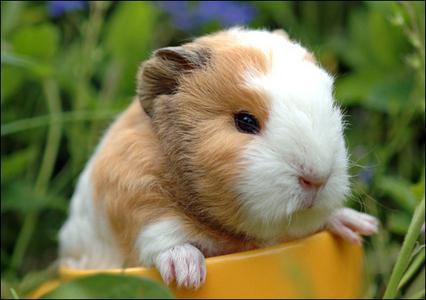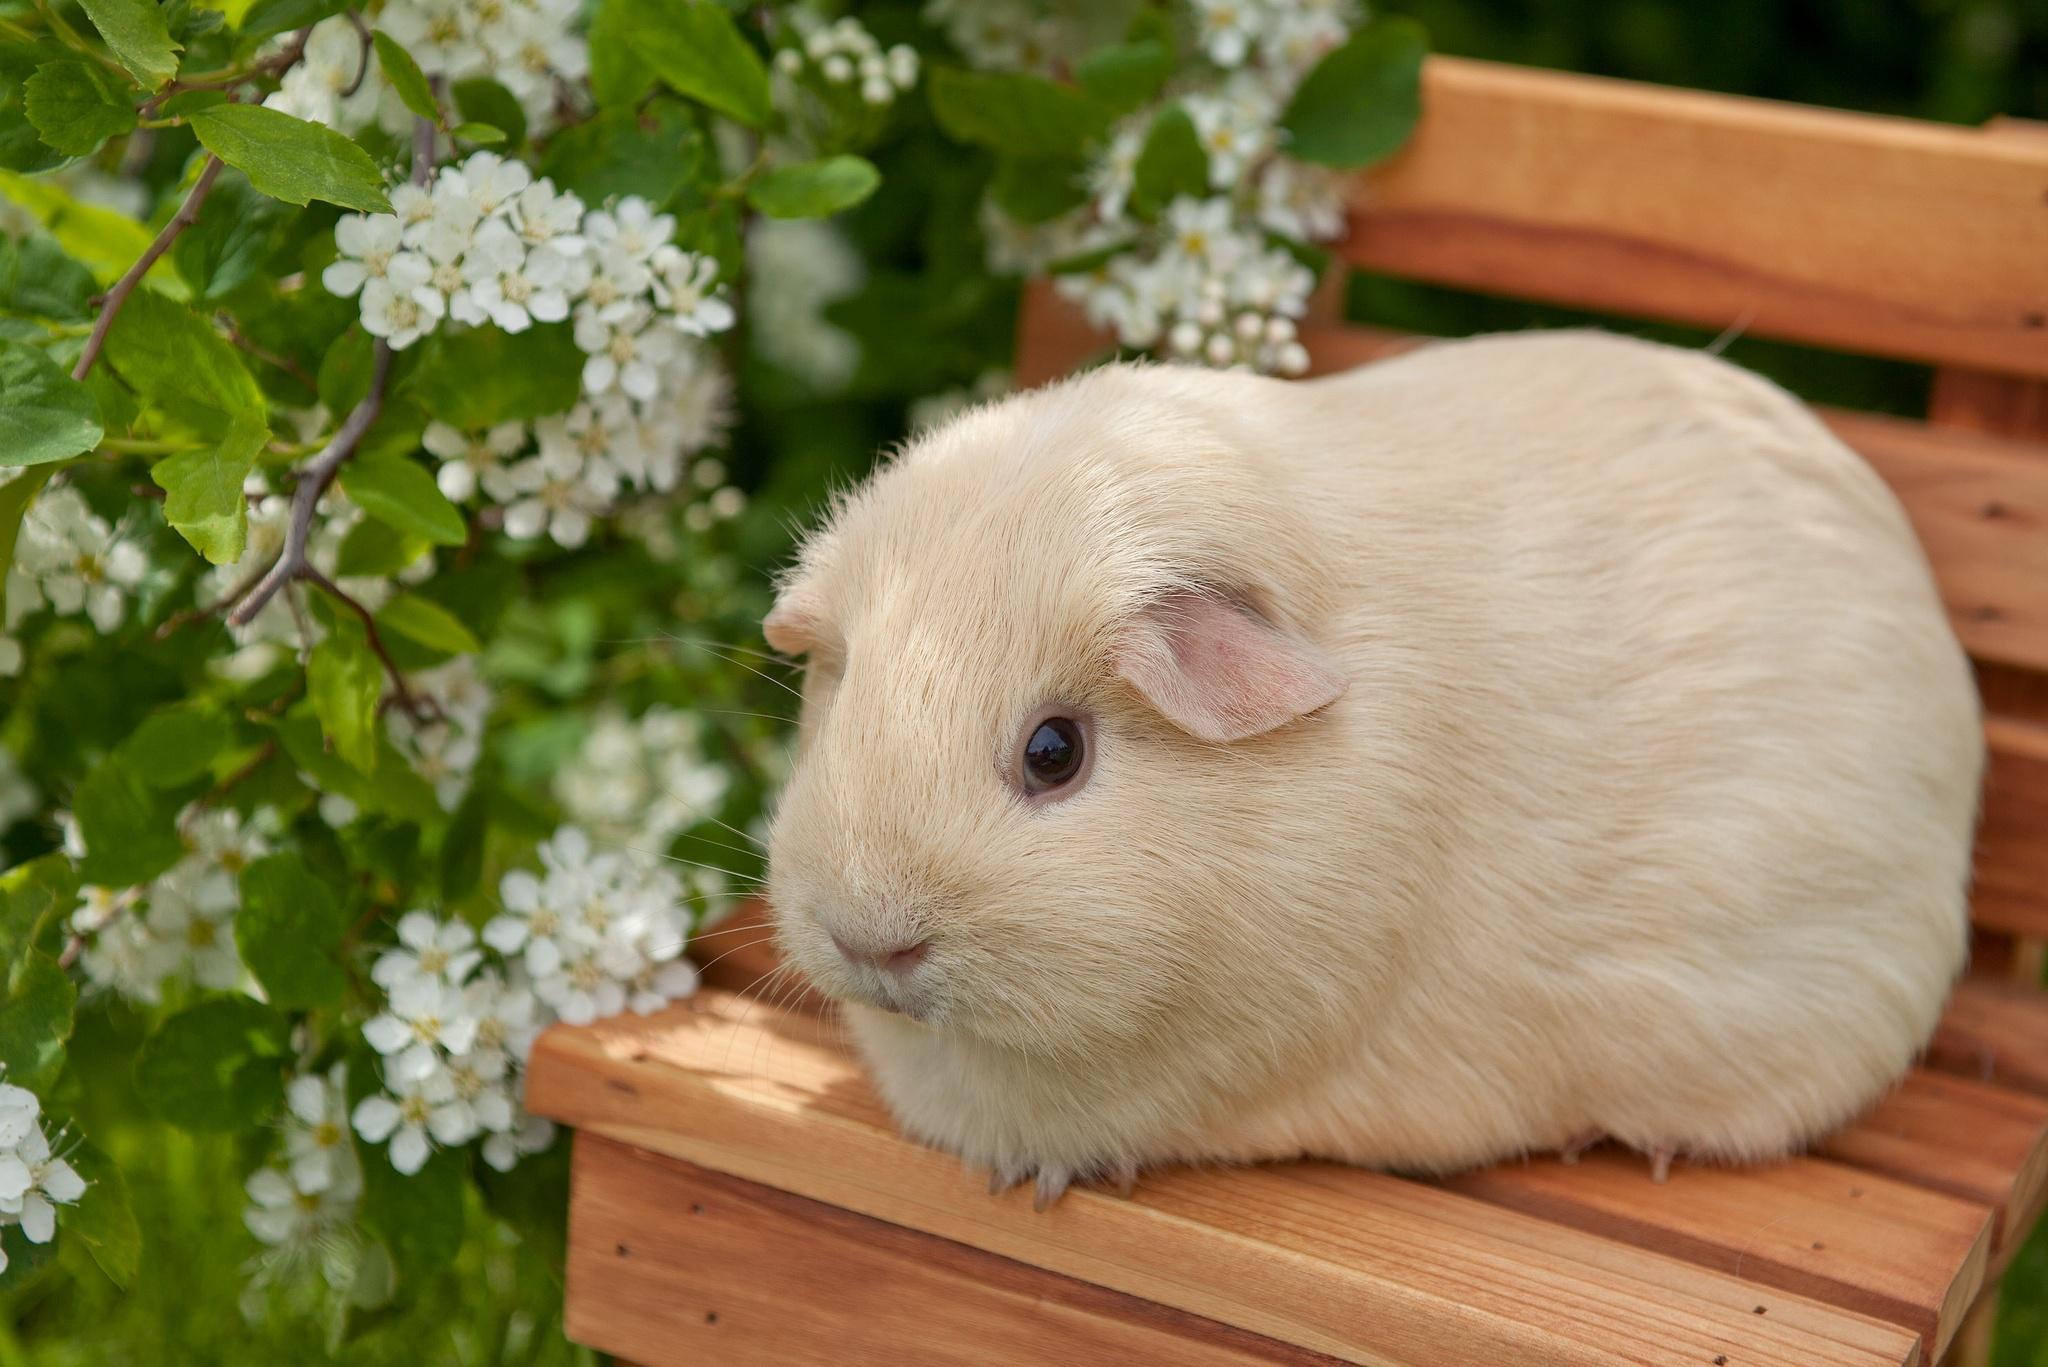The first image is the image on the left, the second image is the image on the right. For the images displayed, is the sentence "At least one guinea pig has a brown face with a white stripe." factually correct? Answer yes or no. Yes. 